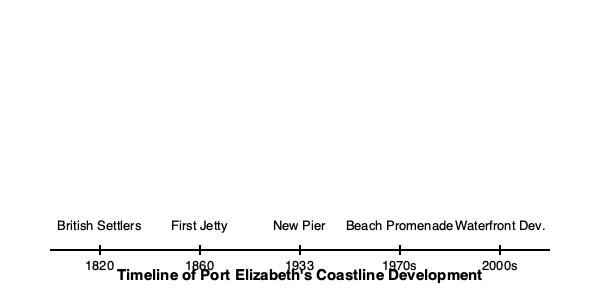Based on the timeline of Port Elizabeth's coastline development, which event marked a significant shift from purely functional maritime infrastructure to recreational amenities for residents and tourists? To answer this question, we need to analyze the events on the timeline chronologically:

1. 1820: British Settlers arrived, establishing the foundation of Port Elizabeth.
2. 1860: The first jetty was built, primarily for maritime trade purposes.
3. 1933: A new pier was constructed, likely to accommodate larger ships and increased trade.
4. 1970s: The beach promenade was developed.
5. 2000s: Waterfront development began.

The first three events (British Settlers, First Jetty, and New Pier) were primarily focused on establishing the settlement and developing maritime infrastructure for trade and transportation.

The significant shift towards recreational amenities occurred in the 1970s with the development of the beach promenade. This marks a turning point where the coastline began to be developed not just for functional purposes, but also for leisure and tourism.

The waterfront development in the 2000s further reinforced this trend, but it was not the initial shift.

Therefore, the construction of the beach promenade in the 1970s represents the pivotal moment when Port Elizabeth's coastline development began to cater to recreational needs alongside its traditional maritime functions.
Answer: 1970s: Beach Promenade development 